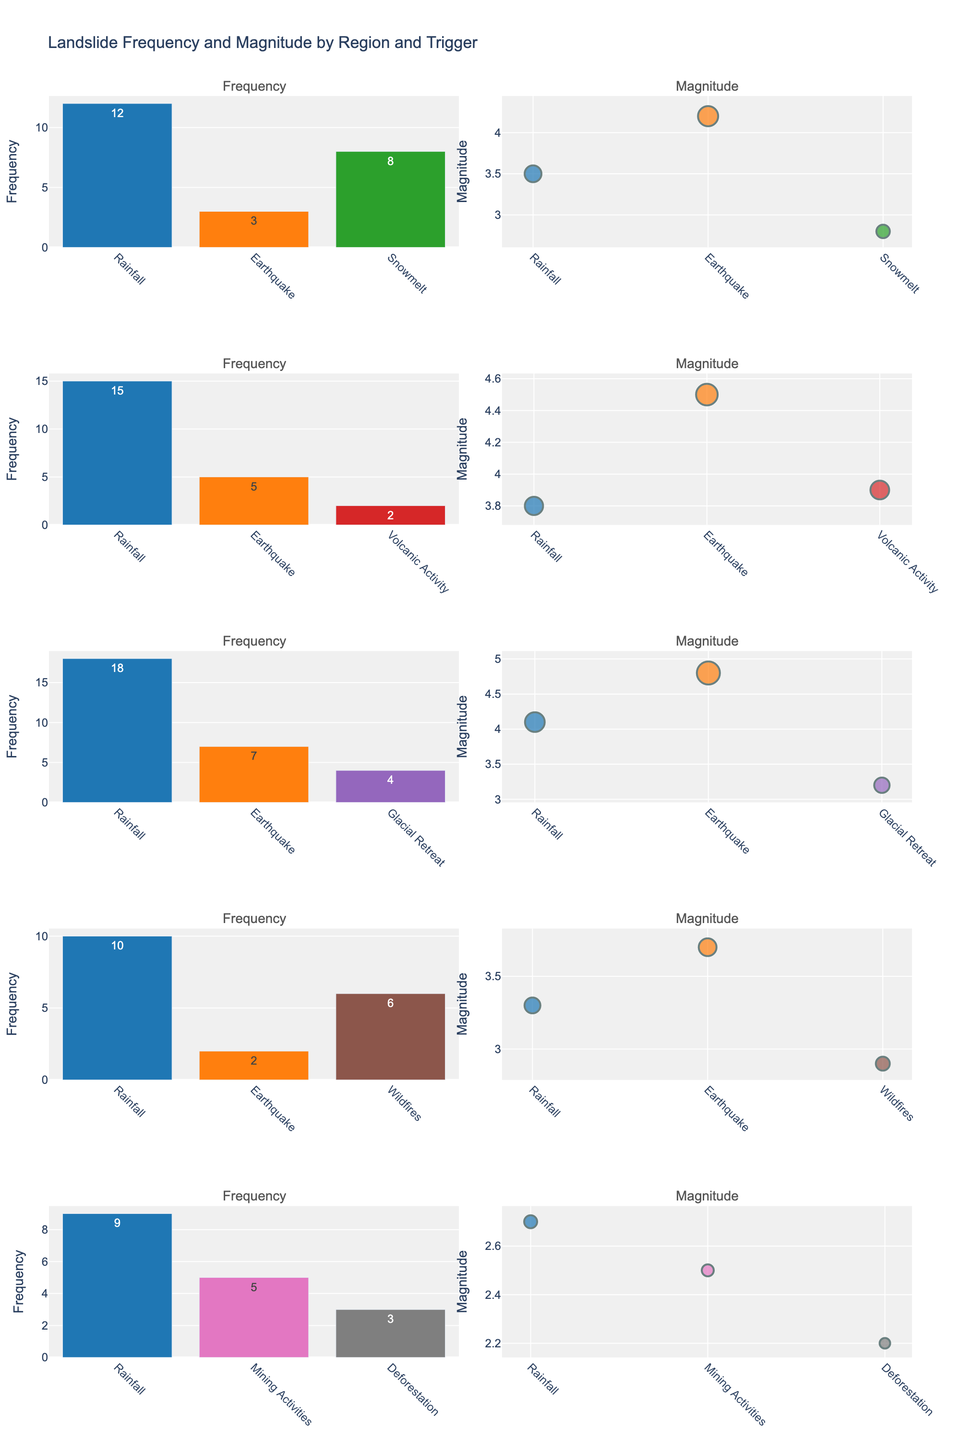What is the title of the plot? The title is displayed at the top of the figure and provides a quick summary of what the figure represents. In this case, it is "Landslide Frequency and Magnitude by Region and Trigger."
Answer: Landslide Frequency and Magnitude by Region and Trigger Which region has the highest frequency of landslides triggered by rainfall? To find this, locate the subplot for "Frequency" for each region and compare the rainfall bars. The highest bar for rainfall is in the Himalayas.
Answer: Himalayas How many triggering factors are shown for the Alps? Each subplot for the Alps will have bars or points representing different triggering factors. Count these unique factors. There are three (Rainfall, Earthquake, Snowmelt).
Answer: 3 What is the approximate magnitude of landslides in the Andes triggered by volcanic activity? In the Andes' "Magnitude" subplot, locate the data point for volcanic activity. The plot shows the magnitude is approximately 3.9.
Answer: 3.9 Which region shows glacial retreat as a trigger for landslides? Look through the subplots to identify where 'Glacial Retreat' is listed as a trigger. It is shown in the Himalayas.
Answer: Himalayas Between the Alps and the Rocky Mountains, which region has a higher average magnitude of landslides triggered by earthquakes? Compare the magnitude for the Earthquake trigger in both regions. The Alps have a magnitude of 4.2 and the Rocky Mountains have 3.7. Thus, the Alps have a higher magnitude.
Answer: Alps In which region do wildfires contribute to landslides? Check the triggering factors listed in the subplots for all regions. Wildfires are shown in the Rocky Mountains.
Answer: Rocky Mountains What are the triggering factors that result in landslides in the Appalachians? Look at the "Frequency" subplot for the Appalachians to see the bars labeled with different triggering factors. They are Rainfall, Mining Activities, and Deforestation.
Answer: Rainfall, Mining Activities, and Deforestation Which region has the smallest magnitude of landslides caused by human activities (Mining, Deforestation)? Identify the magnitudes for Mining Activities and Deforestation in the relevant subplots. The smallest magnitude for these factors is in the Appalachians (Mining Activities 2.5, Deforestation 2.2).
Answer: Appalachians 